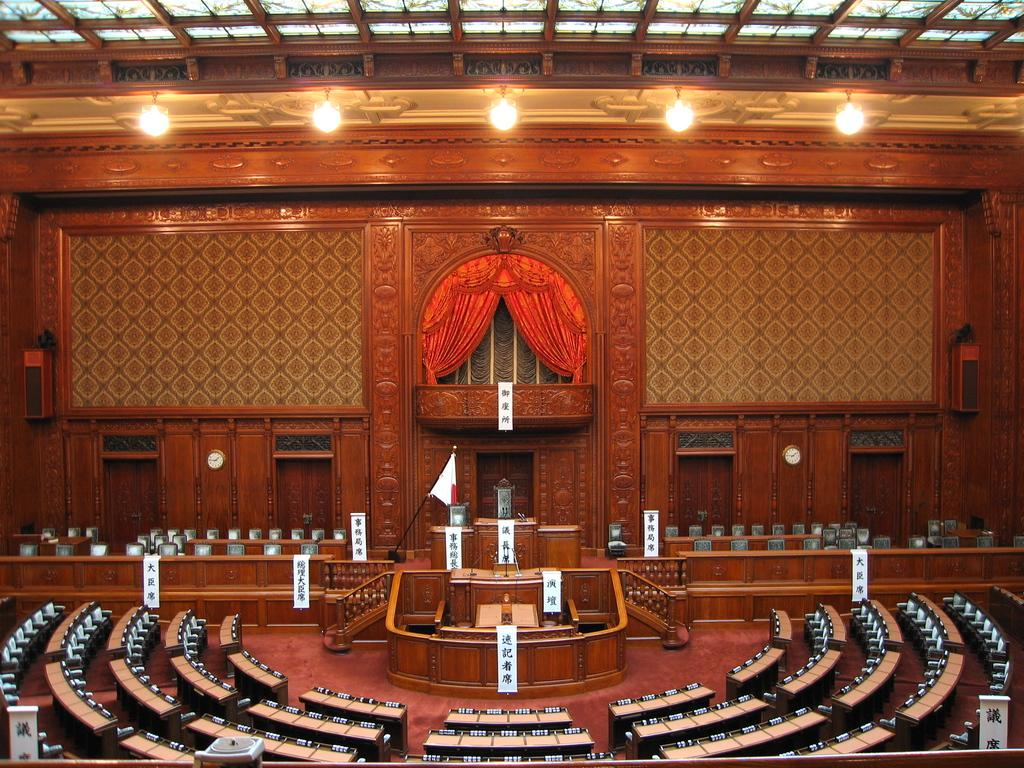What type of furniture is present in the assembly? There are tables and chairs in the assembly. What symbol or representation can be seen in the assembly? There is a flag in the assembly. What type of equipment is present for speakers? There are podiums and speakers in the assembly. What time-related items are present in the assembly? There are clocks in the assembly. What type of lighting is present in the assembly? There are lights in the assembly. What type of decorative or informative items are present in the assembly? There are banners or boards in the assembly. What type of window treatment is present in the assembly? There are curtains in the assembly. How many girls are present in the assembly? The provided facts do not mention the presence of girls in the assembly. What is the size of the assembly? The provided facts do not mention the size of the assembly. 